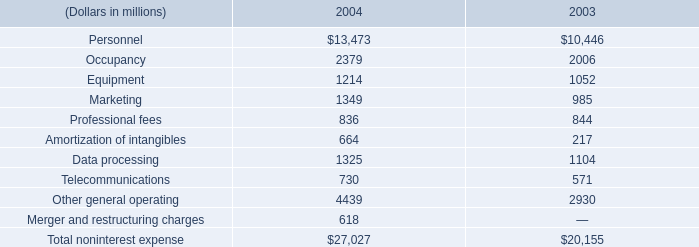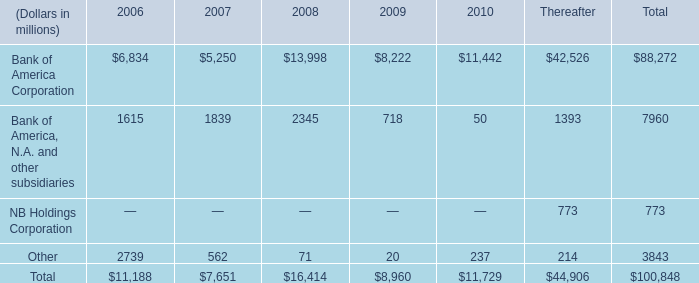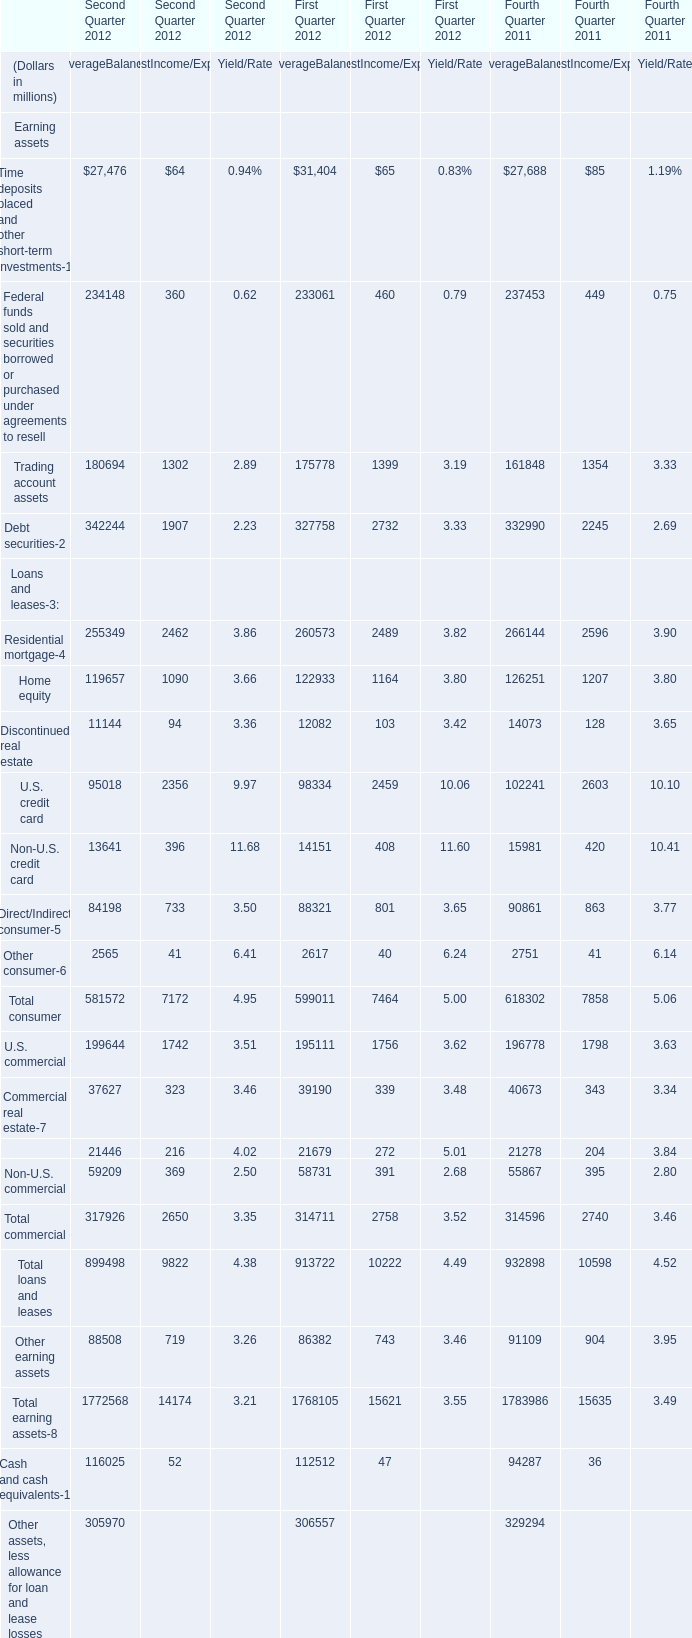What's the sum of the U.S. credit card in the years where Discontinued real estate is positive? (in million) 
Computations: (95018 + 98334)
Answer: 193352.0. 